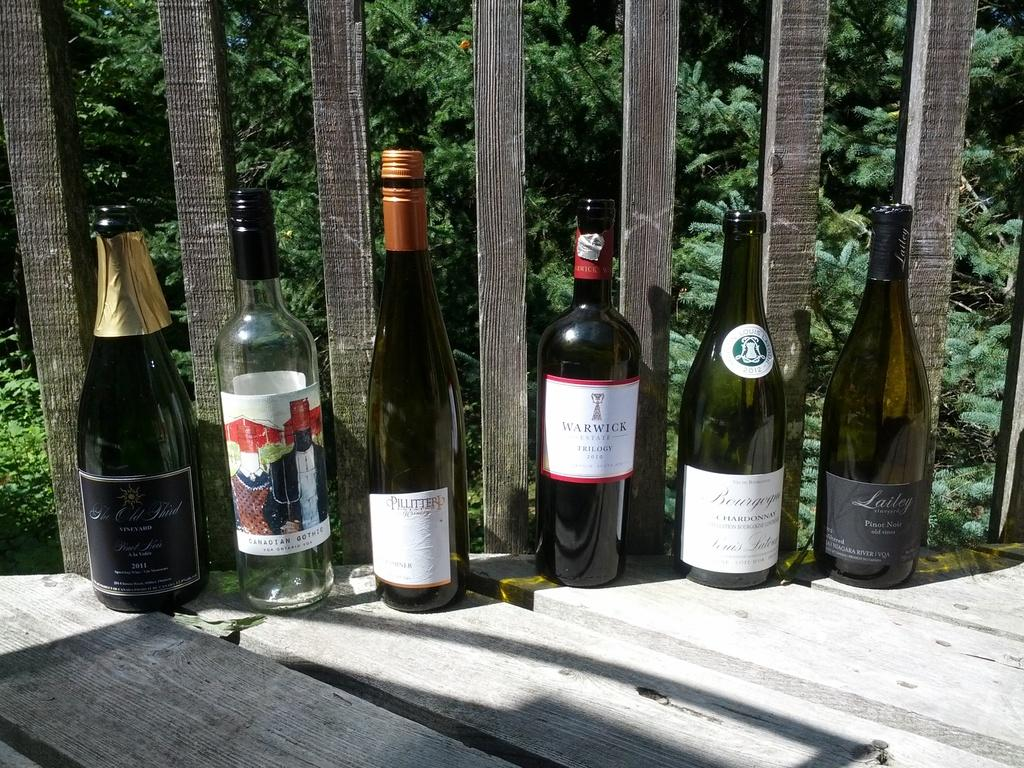How many wine bottles are visible in the image? There are six wine bottles in the image. What is the surface on which the wine bottles are placed? The wine bottles are placed on wood. What type of closure is used on the wine bottles? Each wine bottle has a metal cap. What information can be found on the wine bottles? There are labels attached to each wine bottle. What can be seen in the background of the image? Trees are visible in the background of the image. How does the rat interact with the wine bottles in the image? There is no rat present in the image, so it cannot interact with the wine bottles. 